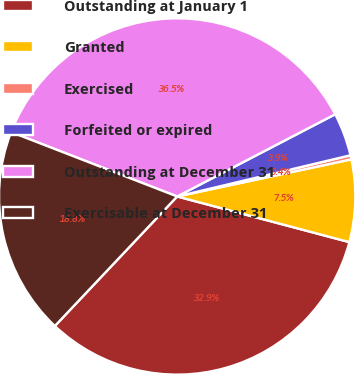<chart> <loc_0><loc_0><loc_500><loc_500><pie_chart><fcel>Outstanding at January 1<fcel>Granted<fcel>Exercised<fcel>Forfeited or expired<fcel>Outstanding at December 31<fcel>Exercisable at December 31<nl><fcel>32.92%<fcel>7.47%<fcel>0.37%<fcel>3.92%<fcel>36.48%<fcel>18.84%<nl></chart> 